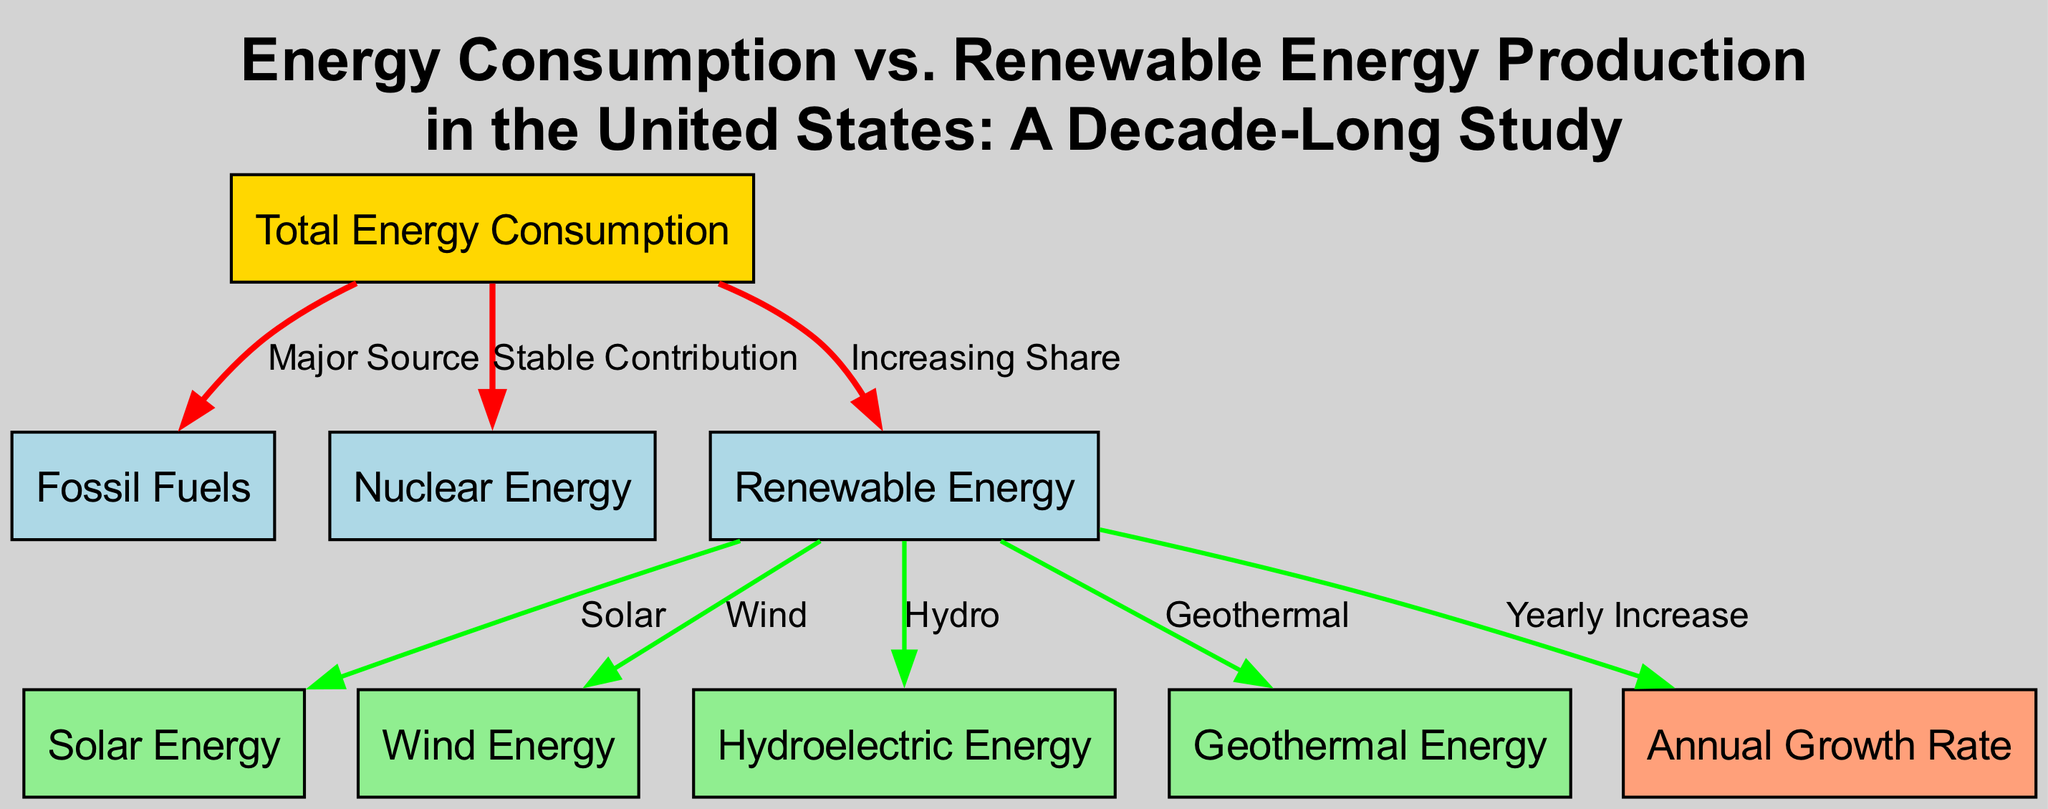What is the primary source of energy consumption in the US? The diagram clearly indicates that fossil fuels are the major source of energy consumption, as it connects to the total energy consumption node with a "Major Source" label.
Answer: Fossil Fuels Which energy source has a "Stable Contribution" to total energy consumption? The diagram shows that nuclear energy is labeled with "Stable Contribution," depicting that its share in total energy consumption remains relatively unchanged over time.
Answer: Nuclear Energy How many types of renewable energy sources are indicated in the diagram? By examining the nodes connected to the renewable energy node, there are four distinct types: solar, wind, hydro, and geothermal, indicating a total of four renewable energy sources.
Answer: Four What trend is indicated for solar energy production? The connection from renewable energy to solar energy with the label "Solar" suggests that solar energy production has seen significant growth over the period analyzed in the diagram.
Answer: Significant growth What is the role of hydroelectric power according to the diagram? The diagram connects hydroelectric energy with the renewable energy node, labeled "Hydro," indicating that it serves as a steady source of renewable energy in the US.
Answer: Steady source What does the "Annual Growth Rate" node represent? The label connected to renewable energy indicates that the "Annual Growth Rate" node serves as a key performance indicator for measuring the yearly percentage increase in renewable energy production.
Answer: Key performance indicator Which renewable energy source is described as relatively small but growing? The diagram links geothermal energy to renewable energy with the description that identifies it as relatively small in scale but experiencing growth over time.
Answer: Geothermal Energy How does the contribution of renewable energy to total energy consumption change over time? The diagram visually illustrates that renewable energy's contribution is rising, as indicated by its labeled connection to the total energy consumption node, reflecting an increasing share.
Answer: Rising 